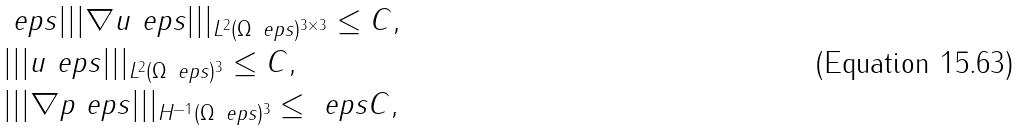<formula> <loc_0><loc_0><loc_500><loc_500>& \ e p s | | | \nabla { u } _ { \ } e p s | | | _ { L ^ { 2 } ( \Omega _ { \ } e p s ) ^ { 3 \times 3 } } \leq C , \\ & | | | { u } _ { \ } e p s | | | _ { L ^ { 2 } ( \Omega _ { \ } e p s ) ^ { 3 } } \leq C , \\ & | | | \nabla p _ { \ } e p s | | | _ { H ^ { - 1 } ( \Omega _ { \ } e p s ) ^ { 3 } } \leq \ e p s C ,</formula> 